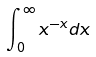Convert formula to latex. <formula><loc_0><loc_0><loc_500><loc_500>\int _ { 0 } ^ { \infty } x ^ { - x } d x</formula> 